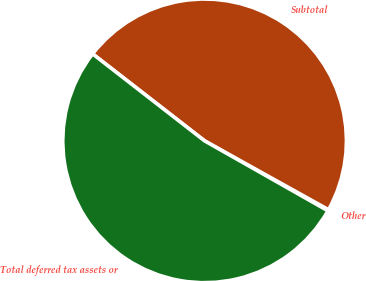Convert chart to OTSL. <chart><loc_0><loc_0><loc_500><loc_500><pie_chart><fcel>Other<fcel>Subtotal<fcel>Total deferred tax assets or<nl><fcel>0.14%<fcel>47.56%<fcel>52.3%<nl></chart> 